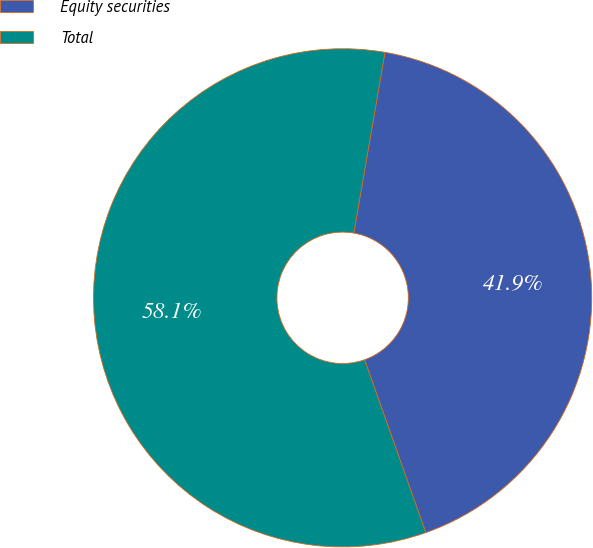Convert chart to OTSL. <chart><loc_0><loc_0><loc_500><loc_500><pie_chart><fcel>Equity securities<fcel>Total<nl><fcel>41.86%<fcel>58.14%<nl></chart> 